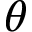<formula> <loc_0><loc_0><loc_500><loc_500>\theta</formula> 